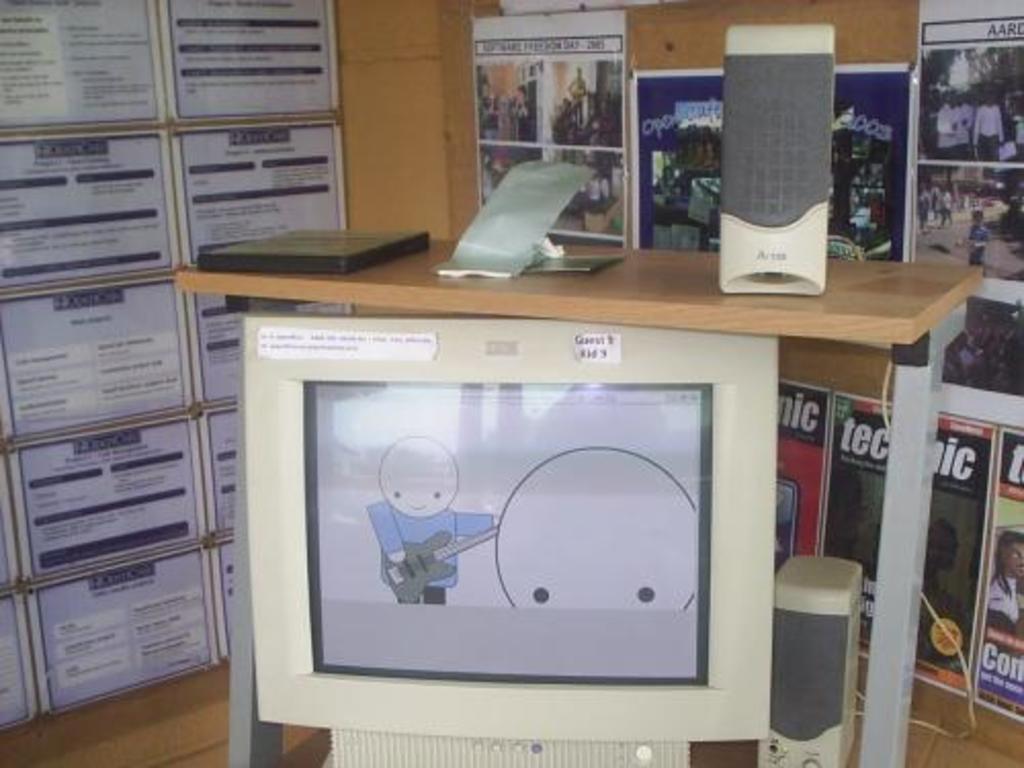In one or two sentences, can you explain what this image depicts? On the right side, there is a speaker and other objects on the wooden table. Below this, there is a monitor and a speaker on the shelf. In the background, there are posters pasted on the wall. 